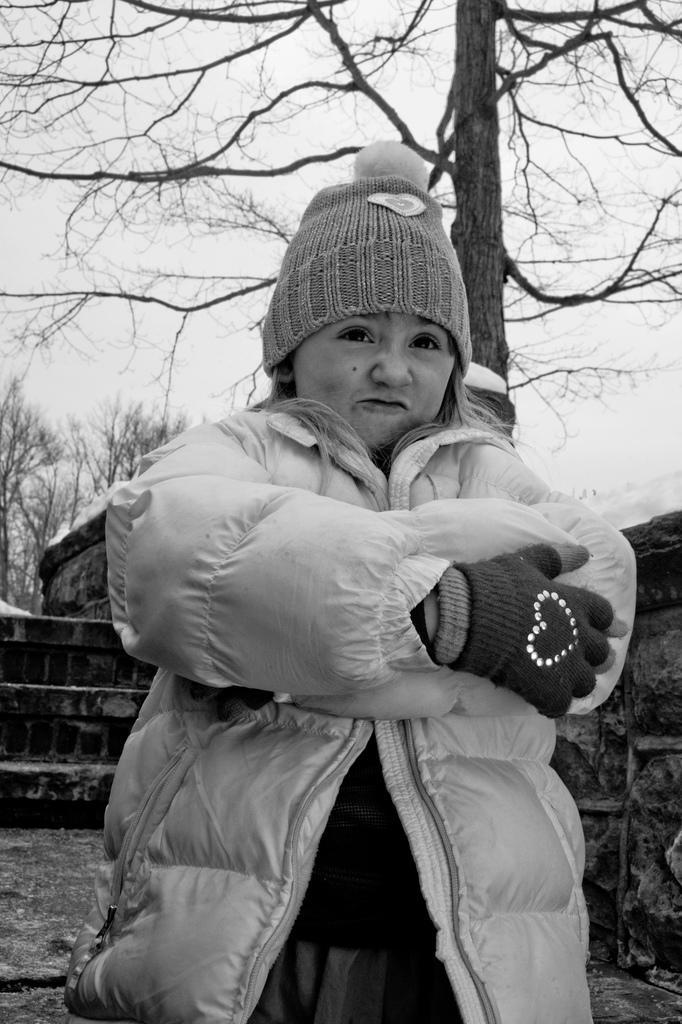Describe this image in one or two sentences. In this image I can see the person with the jacket and cap. In the background I can see the wall, many trees and the sky. And this is a black and white image. 